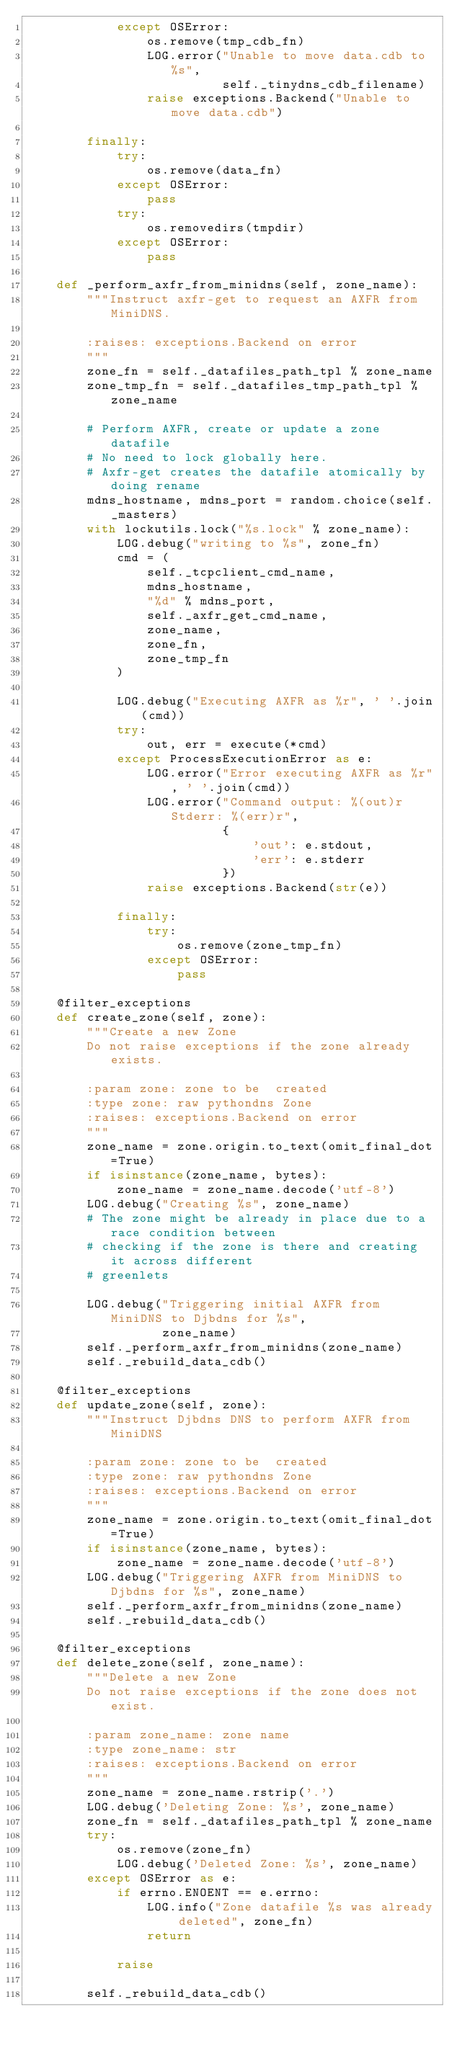<code> <loc_0><loc_0><loc_500><loc_500><_Python_>            except OSError:
                os.remove(tmp_cdb_fn)
                LOG.error("Unable to move data.cdb to %s",
                          self._tinydns_cdb_filename)
                raise exceptions.Backend("Unable to move data.cdb")

        finally:
            try:
                os.remove(data_fn)
            except OSError:
                pass
            try:
                os.removedirs(tmpdir)
            except OSError:
                pass

    def _perform_axfr_from_minidns(self, zone_name):
        """Instruct axfr-get to request an AXFR from MiniDNS.

        :raises: exceptions.Backend on error
        """
        zone_fn = self._datafiles_path_tpl % zone_name
        zone_tmp_fn = self._datafiles_tmp_path_tpl % zone_name

        # Perform AXFR, create or update a zone datafile
        # No need to lock globally here.
        # Axfr-get creates the datafile atomically by doing rename
        mdns_hostname, mdns_port = random.choice(self._masters)
        with lockutils.lock("%s.lock" % zone_name):
            LOG.debug("writing to %s", zone_fn)
            cmd = (
                self._tcpclient_cmd_name,
                mdns_hostname,
                "%d" % mdns_port,
                self._axfr_get_cmd_name,
                zone_name,
                zone_fn,
                zone_tmp_fn
            )

            LOG.debug("Executing AXFR as %r", ' '.join(cmd))
            try:
                out, err = execute(*cmd)
            except ProcessExecutionError as e:
                LOG.error("Error executing AXFR as %r", ' '.join(cmd))
                LOG.error("Command output: %(out)r Stderr: %(err)r",
                          {
                              'out': e.stdout,
                              'err': e.stderr
                          })
                raise exceptions.Backend(str(e))

            finally:
                try:
                    os.remove(zone_tmp_fn)
                except OSError:
                    pass

    @filter_exceptions
    def create_zone(self, zone):
        """Create a new Zone
        Do not raise exceptions if the zone already exists.

        :param zone: zone to be  created
        :type zone: raw pythondns Zone
        :raises: exceptions.Backend on error
        """
        zone_name = zone.origin.to_text(omit_final_dot=True)
        if isinstance(zone_name, bytes):
            zone_name = zone_name.decode('utf-8')
        LOG.debug("Creating %s", zone_name)
        # The zone might be already in place due to a race condition between
        # checking if the zone is there and creating it across different
        # greenlets

        LOG.debug("Triggering initial AXFR from MiniDNS to Djbdns for %s",
                  zone_name)
        self._perform_axfr_from_minidns(zone_name)
        self._rebuild_data_cdb()

    @filter_exceptions
    def update_zone(self, zone):
        """Instruct Djbdns DNS to perform AXFR from MiniDNS

        :param zone: zone to be  created
        :type zone: raw pythondns Zone
        :raises: exceptions.Backend on error
        """
        zone_name = zone.origin.to_text(omit_final_dot=True)
        if isinstance(zone_name, bytes):
            zone_name = zone_name.decode('utf-8')
        LOG.debug("Triggering AXFR from MiniDNS to Djbdns for %s", zone_name)
        self._perform_axfr_from_minidns(zone_name)
        self._rebuild_data_cdb()

    @filter_exceptions
    def delete_zone(self, zone_name):
        """Delete a new Zone
        Do not raise exceptions if the zone does not exist.

        :param zone_name: zone name
        :type zone_name: str
        :raises: exceptions.Backend on error
        """
        zone_name = zone_name.rstrip('.')
        LOG.debug('Deleting Zone: %s', zone_name)
        zone_fn = self._datafiles_path_tpl % zone_name
        try:
            os.remove(zone_fn)
            LOG.debug('Deleted Zone: %s', zone_name)
        except OSError as e:
            if errno.ENOENT == e.errno:
                LOG.info("Zone datafile %s was already deleted", zone_fn)
                return

            raise

        self._rebuild_data_cdb()
</code> 